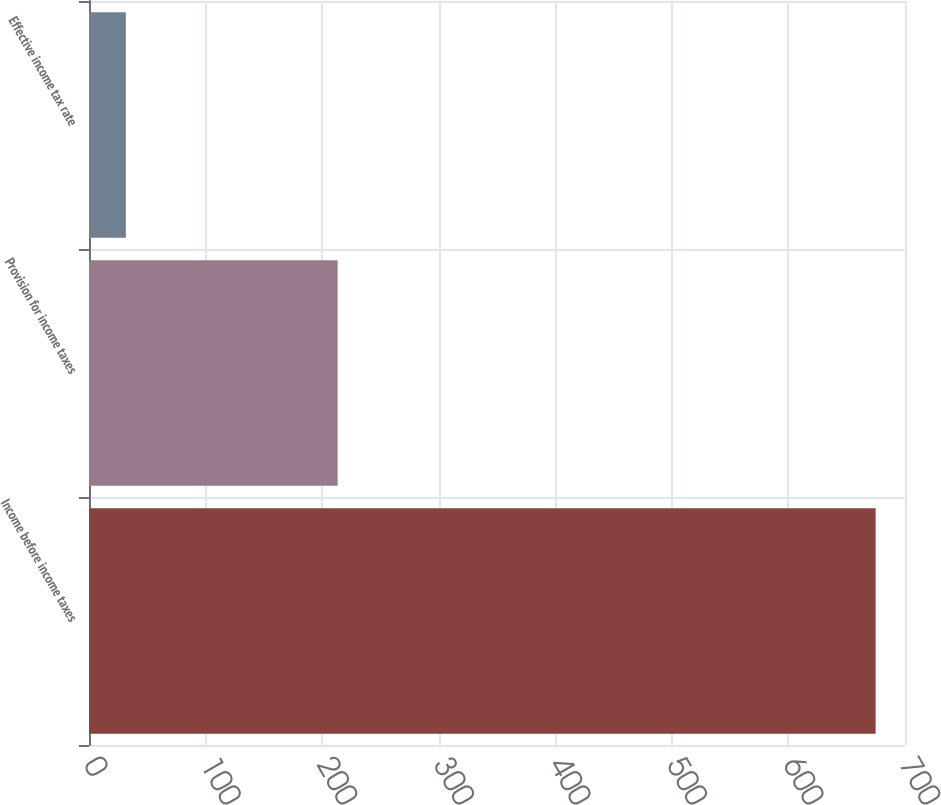Convert chart. <chart><loc_0><loc_0><loc_500><loc_500><bar_chart><fcel>Income before income taxes<fcel>Provision for income taxes<fcel>Effective income tax rate<nl><fcel>674.8<fcel>213.3<fcel>31.6<nl></chart> 